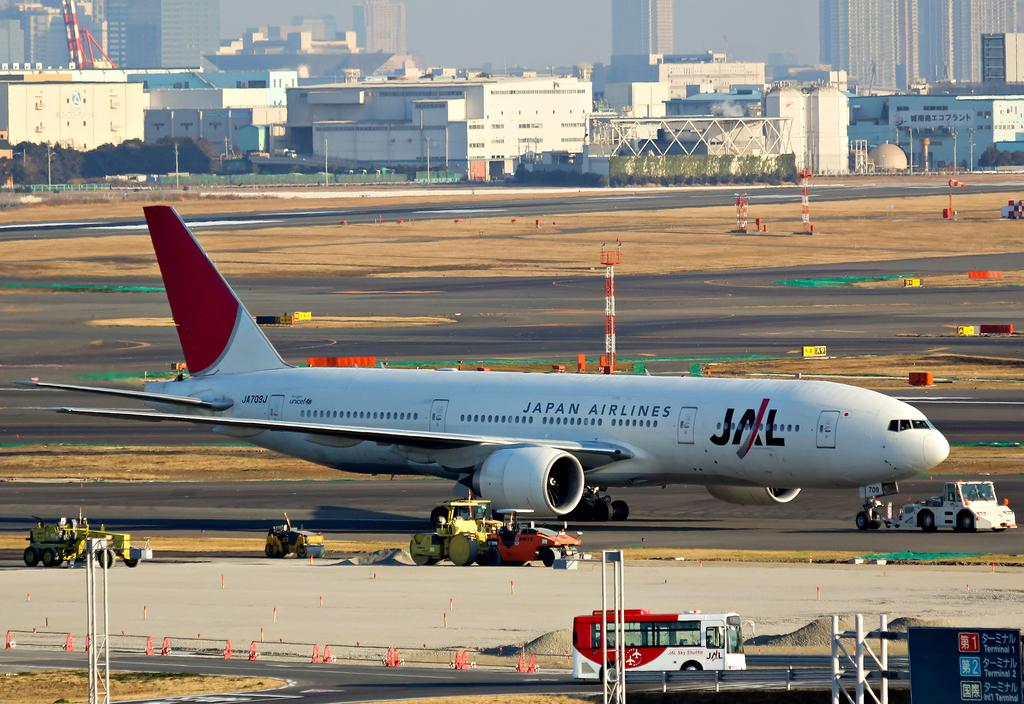<image>
Summarize the visual content of the image. A Japan airlines plane taxis on the runway. 